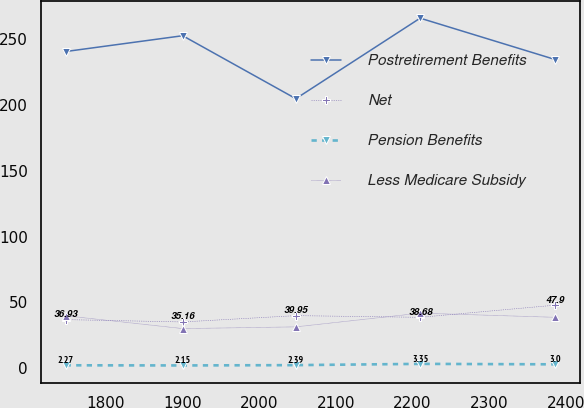Convert chart to OTSL. <chart><loc_0><loc_0><loc_500><loc_500><line_chart><ecel><fcel>Postretirement Benefits<fcel>Net<fcel>Pension Benefits<fcel>Less Medicare Subsidy<nl><fcel>1747.52<fcel>240.37<fcel>36.93<fcel>2.27<fcel>39.85<nl><fcel>1900.22<fcel>252.38<fcel>35.16<fcel>2.15<fcel>30.12<nl><fcel>2047.77<fcel>204.59<fcel>39.95<fcel>2.39<fcel>31.43<nl><fcel>2209.86<fcel>265.7<fcel>38.68<fcel>3.35<fcel>41.84<nl><fcel>2386.18<fcel>234.26<fcel>47.9<fcel>3<fcel>38.68<nl></chart> 